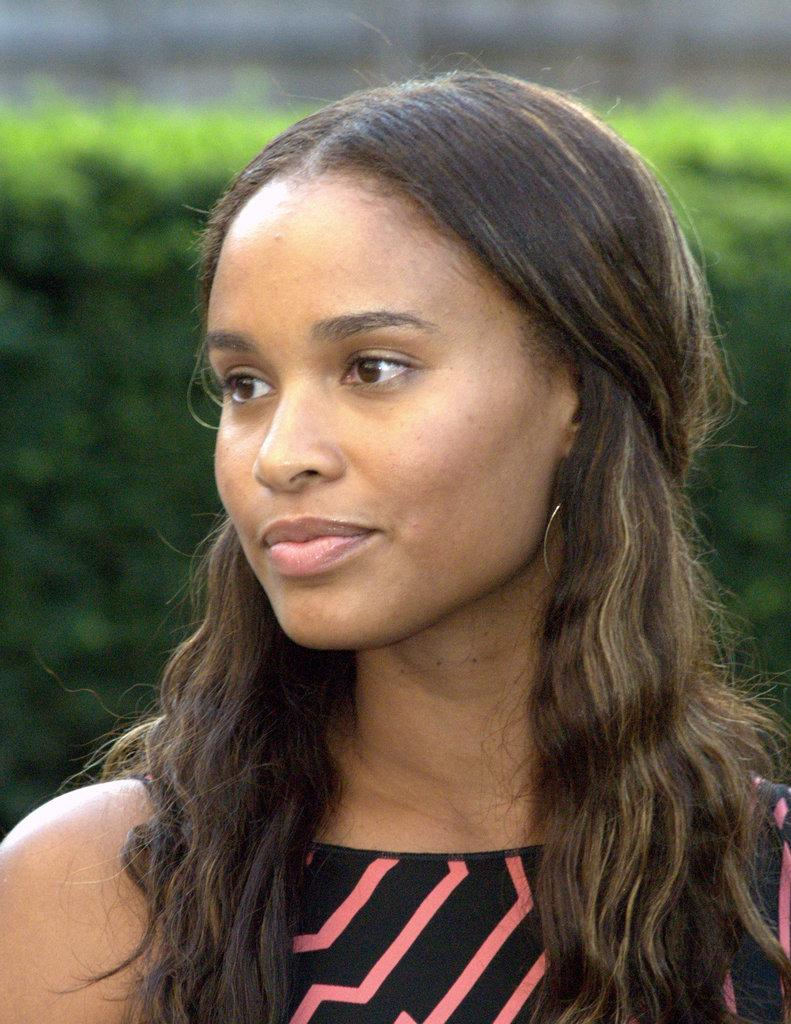What can be observed about the background of the image? The background of the image is blurred, and there is greenery visible. Can you describe the woman in the image? There is a woman in the image, and she is smiling. What type of riddle can be seen being solved by the babies in the image? There are no babies present in the image, and therefore no riddle can be seen being solved. 